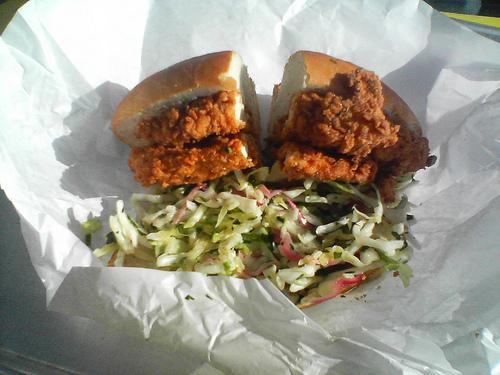How many pieces is the sandwich cut into?
Short answer required. 2. What meat is on the sandwich?
Quick response, please. Chicken. Is that a burn on the person's hand?
Concise answer only. No. What comes with the sandwich?
Concise answer only. Coleslaw. 